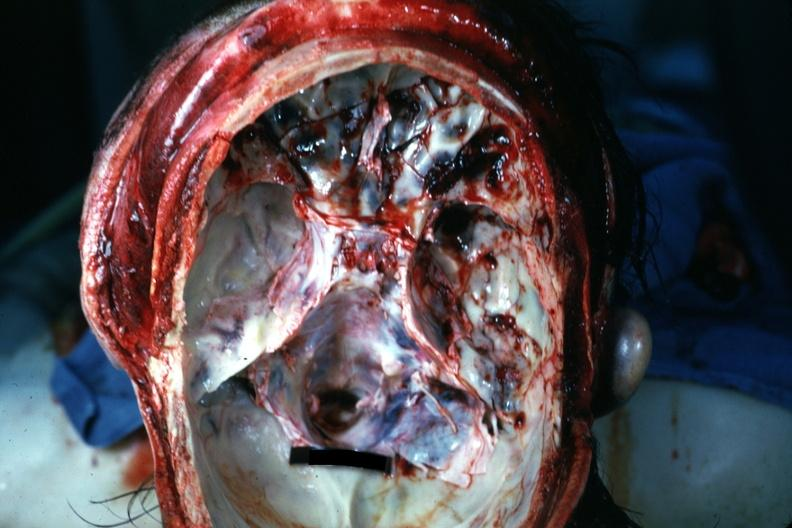what is present?
Answer the question using a single word or phrase. Bone, calvarium 